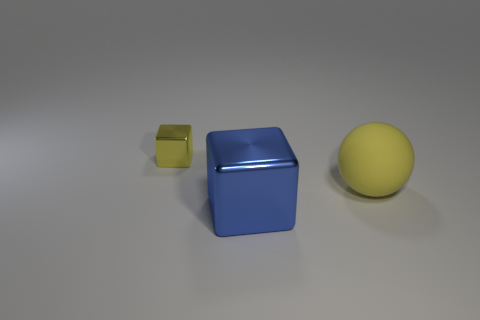Are there any other big cyan balls made of the same material as the ball?
Offer a terse response. No. Is the large rubber ball the same color as the small cube?
Give a very brief answer. Yes. The thing that is in front of the yellow shiny object and behind the large blue shiny block is made of what material?
Ensure brevity in your answer.  Rubber. What is the color of the tiny metallic cube?
Make the answer very short. Yellow. How many other large objects are the same shape as the large blue metallic object?
Provide a short and direct response. 0. Is the material of the thing in front of the yellow rubber sphere the same as the yellow thing that is in front of the tiny cube?
Make the answer very short. No. What size is the thing on the left side of the blue cube that is in front of the tiny yellow object?
Make the answer very short. Small. Is there any other thing that is the same size as the ball?
Make the answer very short. Yes. There is a small object that is the same shape as the big shiny thing; what is its material?
Provide a short and direct response. Metal. There is a yellow thing in front of the tiny yellow object; is its shape the same as the metal object that is in front of the sphere?
Keep it short and to the point. No. 